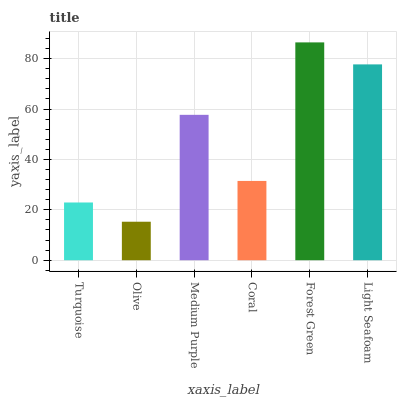Is Medium Purple the minimum?
Answer yes or no. No. Is Medium Purple the maximum?
Answer yes or no. No. Is Medium Purple greater than Olive?
Answer yes or no. Yes. Is Olive less than Medium Purple?
Answer yes or no. Yes. Is Olive greater than Medium Purple?
Answer yes or no. No. Is Medium Purple less than Olive?
Answer yes or no. No. Is Medium Purple the high median?
Answer yes or no. Yes. Is Coral the low median?
Answer yes or no. Yes. Is Olive the high median?
Answer yes or no. No. Is Olive the low median?
Answer yes or no. No. 